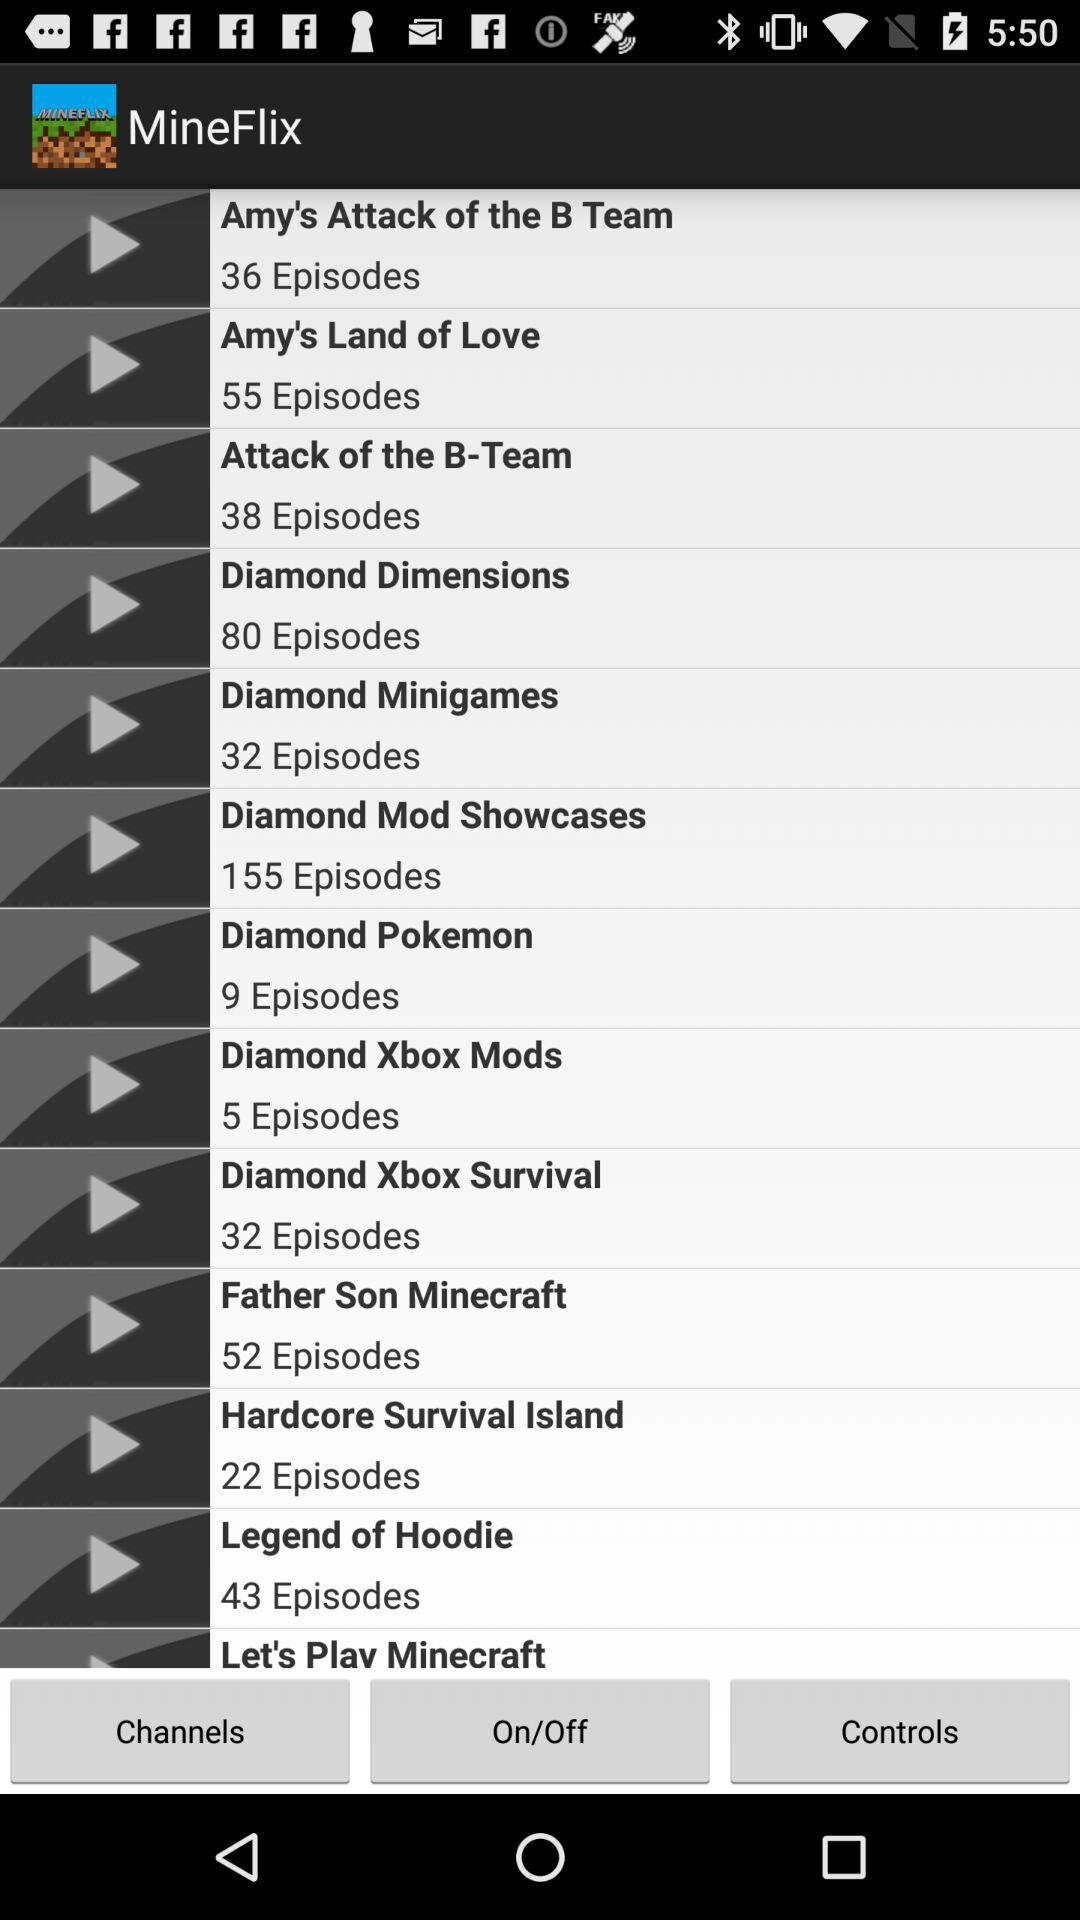What is the application name? The application name is "MineFlix". 